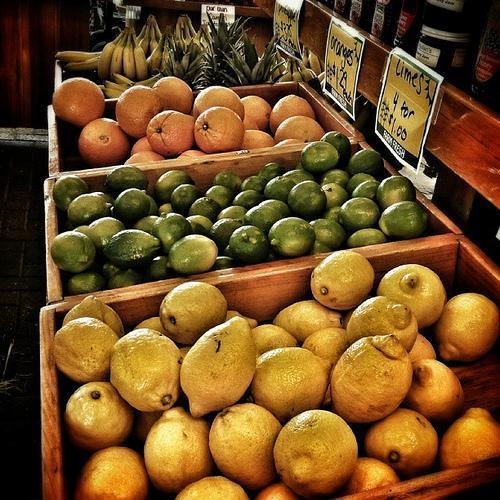How many oranges are visible?
Give a very brief answer. 15. How many produce signs are displayed?
Give a very brief answer. 3. How many signs are to the right of the sign for the oranges?
Give a very brief answer. 1. 